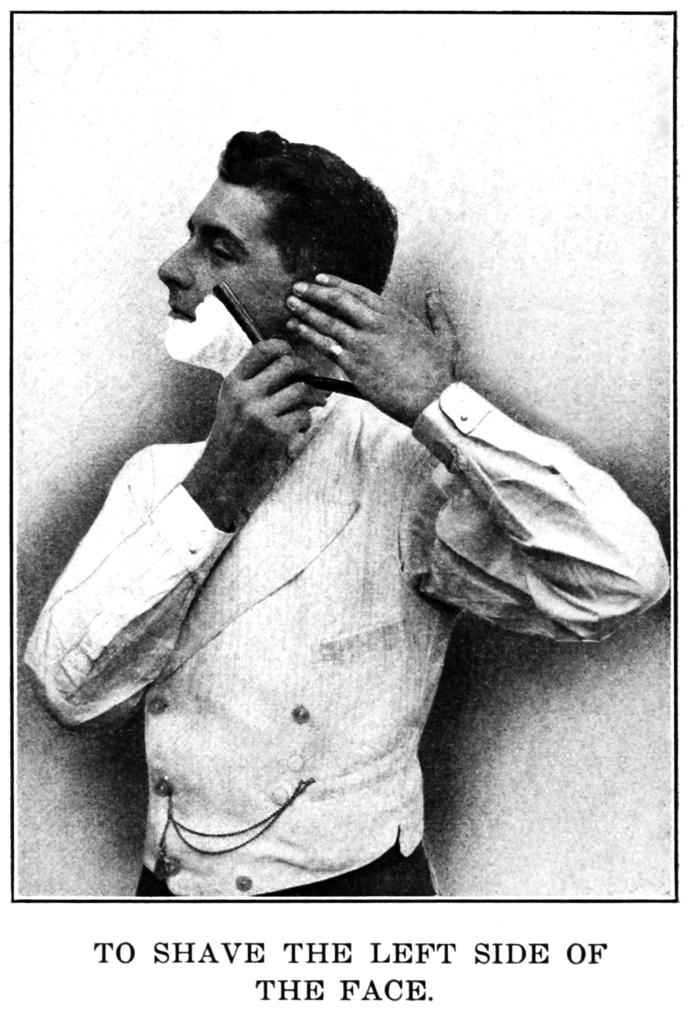What is present on the paper in the image? The paper contains an image of a person. What is the person in the image doing? The person in the image is holding an object. Are there any words on the paper? Yes, there are words on the paper. What type of teeth can be seen in the image? There are no teeth visible in the image; it features a paper with an image of a person holding an object. 